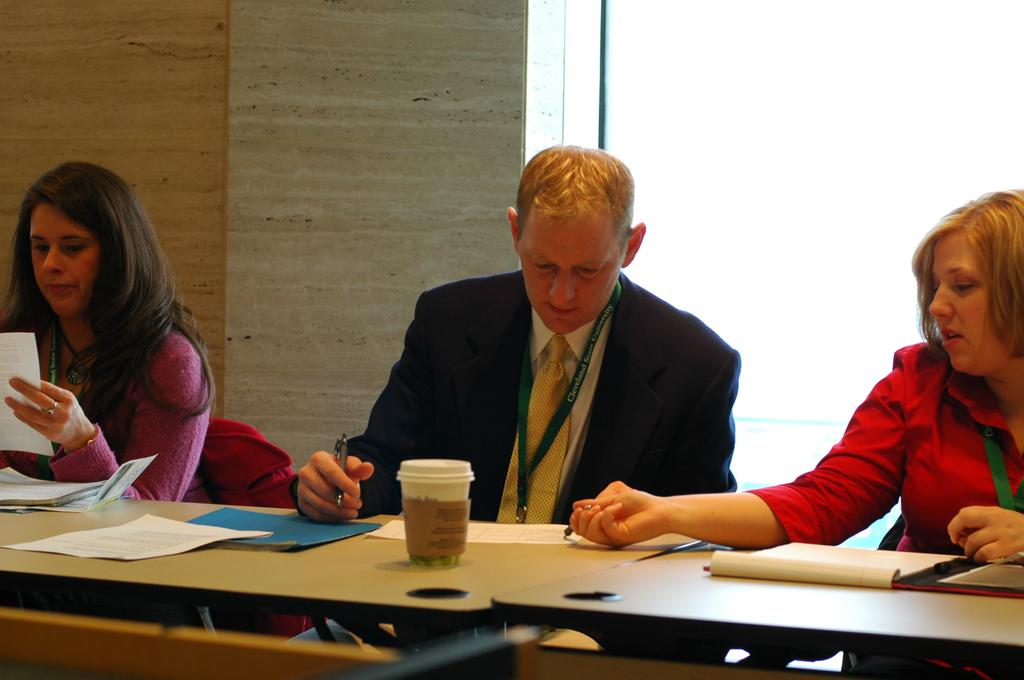How many people are in the image? There are two women and a man in the image. What are the individuals doing in the image? The individuals are seated on chairs. What is in front of the seated individuals? There is a table in front of them. What can be seen on the table? A coffee cup and papers are on the table. What type of juice is being served in the morning in the image? There is no juice or mention of morning in the image; it only shows two women, a man, chairs, a table, a coffee cup, and papers. 